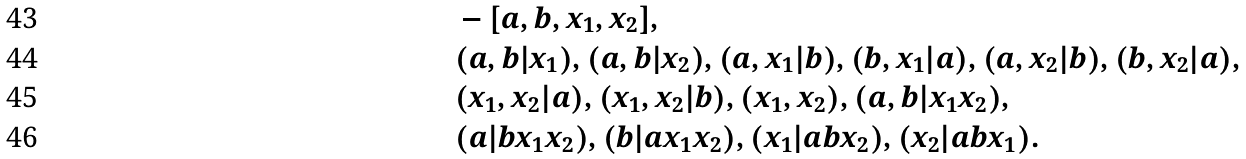Convert formula to latex. <formula><loc_0><loc_0><loc_500><loc_500>& - [ a , b , x _ { 1 } , x _ { 2 } ] , \\ & ( a , b | x _ { 1 } ) , ( a , b | x _ { 2 } ) , ( a , x _ { 1 } | b ) , ( b , x _ { 1 } | a ) , ( a , x _ { 2 } | b ) , ( b , x _ { 2 } | a ) , \\ & ( x _ { 1 } , x _ { 2 } | a ) , ( x _ { 1 } , x _ { 2 } | b ) , ( x _ { 1 } , x _ { 2 } ) , ( a , b | x _ { 1 } x _ { 2 } ) , \\ & ( a | b x _ { 1 } x _ { 2 } ) , ( b | a x _ { 1 } x _ { 2 } ) , ( x _ { 1 } | a b x _ { 2 } ) , ( x _ { 2 } | a b x _ { 1 } ) .</formula> 